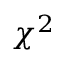Convert formula to latex. <formula><loc_0><loc_0><loc_500><loc_500>\chi ^ { 2 }</formula> 